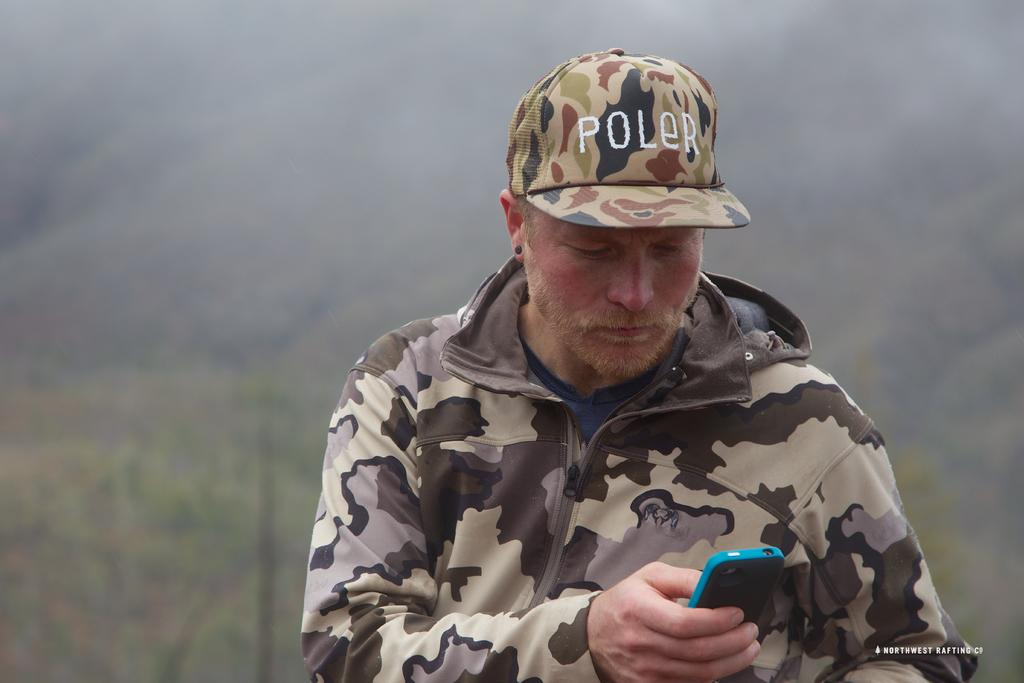What is the main subject of the image? There is a person in the image. What type of clothing is the person wearing? The person is wearing a sweater and a cap. What activity is the person engaged in? The person is operating a mobile phone. What type of noise can be heard coming from the person's glove in the image? There is no glove present in the image, and therefore no such noise can be heard. 